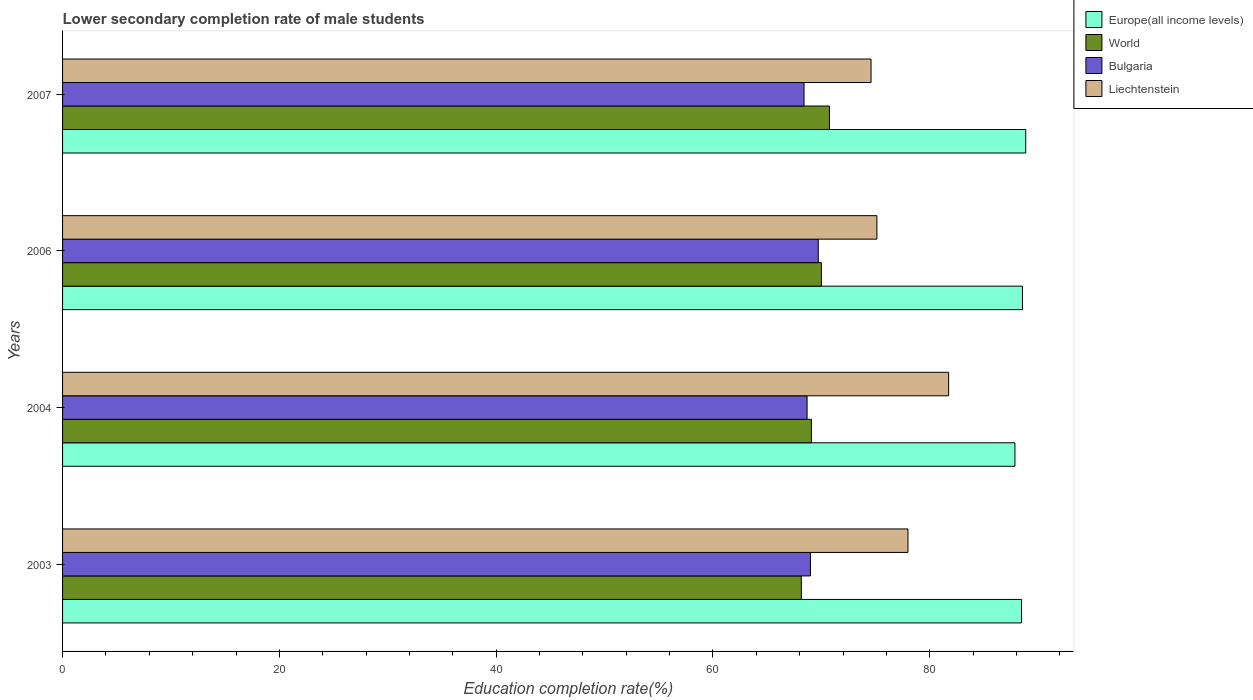Are the number of bars on each tick of the Y-axis equal?
Give a very brief answer. Yes. How many bars are there on the 2nd tick from the bottom?
Ensure brevity in your answer.  4. In how many cases, is the number of bars for a given year not equal to the number of legend labels?
Your answer should be compact. 0. What is the lower secondary completion rate of male students in Bulgaria in 2006?
Make the answer very short. 69.71. Across all years, what is the maximum lower secondary completion rate of male students in Europe(all income levels)?
Provide a succinct answer. 88.85. Across all years, what is the minimum lower secondary completion rate of male students in World?
Your response must be concise. 68.15. In which year was the lower secondary completion rate of male students in Europe(all income levels) maximum?
Your answer should be compact. 2007. What is the total lower secondary completion rate of male students in Europe(all income levels) in the graph?
Provide a succinct answer. 353.73. What is the difference between the lower secondary completion rate of male students in Europe(all income levels) in 2004 and that in 2006?
Your answer should be very brief. -0.69. What is the difference between the lower secondary completion rate of male students in Europe(all income levels) in 2007 and the lower secondary completion rate of male students in Liechtenstein in 2003?
Offer a very short reply. 10.86. What is the average lower secondary completion rate of male students in Bulgaria per year?
Make the answer very short. 68.95. In the year 2004, what is the difference between the lower secondary completion rate of male students in Liechtenstein and lower secondary completion rate of male students in Bulgaria?
Your answer should be very brief. 13.06. What is the ratio of the lower secondary completion rate of male students in Liechtenstein in 2003 to that in 2004?
Make the answer very short. 0.95. Is the lower secondary completion rate of male students in World in 2004 less than that in 2007?
Keep it short and to the point. Yes. Is the difference between the lower secondary completion rate of male students in Liechtenstein in 2003 and 2007 greater than the difference between the lower secondary completion rate of male students in Bulgaria in 2003 and 2007?
Your answer should be very brief. Yes. What is the difference between the highest and the second highest lower secondary completion rate of male students in Bulgaria?
Your response must be concise. 0.72. What is the difference between the highest and the lowest lower secondary completion rate of male students in Bulgaria?
Your answer should be very brief. 1.31. What does the 4th bar from the bottom in 2003 represents?
Provide a short and direct response. Liechtenstein. Is it the case that in every year, the sum of the lower secondary completion rate of male students in Bulgaria and lower secondary completion rate of male students in Liechtenstein is greater than the lower secondary completion rate of male students in Europe(all income levels)?
Your answer should be very brief. Yes. What is the difference between two consecutive major ticks on the X-axis?
Ensure brevity in your answer.  20. Does the graph contain grids?
Provide a short and direct response. No. How are the legend labels stacked?
Ensure brevity in your answer.  Vertical. What is the title of the graph?
Your response must be concise. Lower secondary completion rate of male students. What is the label or title of the X-axis?
Keep it short and to the point. Education completion rate(%). What is the label or title of the Y-axis?
Offer a very short reply. Years. What is the Education completion rate(%) in Europe(all income levels) in 2003?
Your answer should be very brief. 88.46. What is the Education completion rate(%) of World in 2003?
Offer a very short reply. 68.15. What is the Education completion rate(%) of Bulgaria in 2003?
Make the answer very short. 68.99. What is the Education completion rate(%) of Liechtenstein in 2003?
Your answer should be very brief. 77.99. What is the Education completion rate(%) in Europe(all income levels) in 2004?
Provide a short and direct response. 87.86. What is the Education completion rate(%) of World in 2004?
Offer a terse response. 69.08. What is the Education completion rate(%) in Bulgaria in 2004?
Provide a short and direct response. 68.68. What is the Education completion rate(%) in Liechtenstein in 2004?
Offer a very short reply. 81.74. What is the Education completion rate(%) of Europe(all income levels) in 2006?
Make the answer very short. 88.55. What is the Education completion rate(%) in World in 2006?
Keep it short and to the point. 70. What is the Education completion rate(%) of Bulgaria in 2006?
Your response must be concise. 69.71. What is the Education completion rate(%) of Liechtenstein in 2006?
Your answer should be compact. 75.12. What is the Education completion rate(%) in Europe(all income levels) in 2007?
Provide a short and direct response. 88.85. What is the Education completion rate(%) of World in 2007?
Your answer should be very brief. 70.75. What is the Education completion rate(%) in Bulgaria in 2007?
Give a very brief answer. 68.4. What is the Education completion rate(%) in Liechtenstein in 2007?
Provide a short and direct response. 74.58. Across all years, what is the maximum Education completion rate(%) in Europe(all income levels)?
Offer a terse response. 88.85. Across all years, what is the maximum Education completion rate(%) of World?
Make the answer very short. 70.75. Across all years, what is the maximum Education completion rate(%) in Bulgaria?
Offer a very short reply. 69.71. Across all years, what is the maximum Education completion rate(%) of Liechtenstein?
Ensure brevity in your answer.  81.74. Across all years, what is the minimum Education completion rate(%) in Europe(all income levels)?
Provide a short and direct response. 87.86. Across all years, what is the minimum Education completion rate(%) in World?
Make the answer very short. 68.15. Across all years, what is the minimum Education completion rate(%) in Bulgaria?
Give a very brief answer. 68.4. Across all years, what is the minimum Education completion rate(%) in Liechtenstein?
Give a very brief answer. 74.58. What is the total Education completion rate(%) of Europe(all income levels) in the graph?
Your answer should be very brief. 353.73. What is the total Education completion rate(%) of World in the graph?
Offer a very short reply. 277.99. What is the total Education completion rate(%) in Bulgaria in the graph?
Provide a succinct answer. 275.79. What is the total Education completion rate(%) in Liechtenstein in the graph?
Provide a short and direct response. 309.44. What is the difference between the Education completion rate(%) in Europe(all income levels) in 2003 and that in 2004?
Keep it short and to the point. 0.6. What is the difference between the Education completion rate(%) of World in 2003 and that in 2004?
Offer a very short reply. -0.93. What is the difference between the Education completion rate(%) of Bulgaria in 2003 and that in 2004?
Keep it short and to the point. 0.31. What is the difference between the Education completion rate(%) in Liechtenstein in 2003 and that in 2004?
Give a very brief answer. -3.75. What is the difference between the Education completion rate(%) in Europe(all income levels) in 2003 and that in 2006?
Provide a short and direct response. -0.09. What is the difference between the Education completion rate(%) in World in 2003 and that in 2006?
Provide a succinct answer. -1.85. What is the difference between the Education completion rate(%) in Bulgaria in 2003 and that in 2006?
Offer a terse response. -0.72. What is the difference between the Education completion rate(%) of Liechtenstein in 2003 and that in 2006?
Your answer should be compact. 2.87. What is the difference between the Education completion rate(%) of Europe(all income levels) in 2003 and that in 2007?
Your response must be concise. -0.39. What is the difference between the Education completion rate(%) of World in 2003 and that in 2007?
Your answer should be very brief. -2.6. What is the difference between the Education completion rate(%) in Bulgaria in 2003 and that in 2007?
Keep it short and to the point. 0.59. What is the difference between the Education completion rate(%) of Liechtenstein in 2003 and that in 2007?
Your response must be concise. 3.41. What is the difference between the Education completion rate(%) in Europe(all income levels) in 2004 and that in 2006?
Provide a succinct answer. -0.69. What is the difference between the Education completion rate(%) of World in 2004 and that in 2006?
Offer a very short reply. -0.92. What is the difference between the Education completion rate(%) in Bulgaria in 2004 and that in 2006?
Ensure brevity in your answer.  -1.03. What is the difference between the Education completion rate(%) of Liechtenstein in 2004 and that in 2006?
Keep it short and to the point. 6.62. What is the difference between the Education completion rate(%) in Europe(all income levels) in 2004 and that in 2007?
Offer a terse response. -1. What is the difference between the Education completion rate(%) in World in 2004 and that in 2007?
Ensure brevity in your answer.  -1.66. What is the difference between the Education completion rate(%) of Bulgaria in 2004 and that in 2007?
Ensure brevity in your answer.  0.28. What is the difference between the Education completion rate(%) in Liechtenstein in 2004 and that in 2007?
Make the answer very short. 7.16. What is the difference between the Education completion rate(%) in Europe(all income levels) in 2006 and that in 2007?
Make the answer very short. -0.3. What is the difference between the Education completion rate(%) in World in 2006 and that in 2007?
Your answer should be compact. -0.75. What is the difference between the Education completion rate(%) in Bulgaria in 2006 and that in 2007?
Offer a very short reply. 1.31. What is the difference between the Education completion rate(%) of Liechtenstein in 2006 and that in 2007?
Your answer should be very brief. 0.54. What is the difference between the Education completion rate(%) of Europe(all income levels) in 2003 and the Education completion rate(%) of World in 2004?
Provide a succinct answer. 19.38. What is the difference between the Education completion rate(%) of Europe(all income levels) in 2003 and the Education completion rate(%) of Bulgaria in 2004?
Provide a succinct answer. 19.78. What is the difference between the Education completion rate(%) in Europe(all income levels) in 2003 and the Education completion rate(%) in Liechtenstein in 2004?
Provide a short and direct response. 6.72. What is the difference between the Education completion rate(%) in World in 2003 and the Education completion rate(%) in Bulgaria in 2004?
Your answer should be very brief. -0.53. What is the difference between the Education completion rate(%) in World in 2003 and the Education completion rate(%) in Liechtenstein in 2004?
Give a very brief answer. -13.59. What is the difference between the Education completion rate(%) of Bulgaria in 2003 and the Education completion rate(%) of Liechtenstein in 2004?
Keep it short and to the point. -12.75. What is the difference between the Education completion rate(%) of Europe(all income levels) in 2003 and the Education completion rate(%) of World in 2006?
Provide a succinct answer. 18.46. What is the difference between the Education completion rate(%) of Europe(all income levels) in 2003 and the Education completion rate(%) of Bulgaria in 2006?
Provide a short and direct response. 18.75. What is the difference between the Education completion rate(%) of Europe(all income levels) in 2003 and the Education completion rate(%) of Liechtenstein in 2006?
Provide a short and direct response. 13.34. What is the difference between the Education completion rate(%) of World in 2003 and the Education completion rate(%) of Bulgaria in 2006?
Offer a very short reply. -1.56. What is the difference between the Education completion rate(%) of World in 2003 and the Education completion rate(%) of Liechtenstein in 2006?
Your response must be concise. -6.97. What is the difference between the Education completion rate(%) in Bulgaria in 2003 and the Education completion rate(%) in Liechtenstein in 2006?
Your answer should be compact. -6.13. What is the difference between the Education completion rate(%) of Europe(all income levels) in 2003 and the Education completion rate(%) of World in 2007?
Offer a terse response. 17.71. What is the difference between the Education completion rate(%) in Europe(all income levels) in 2003 and the Education completion rate(%) in Bulgaria in 2007?
Offer a terse response. 20.06. What is the difference between the Education completion rate(%) of Europe(all income levels) in 2003 and the Education completion rate(%) of Liechtenstein in 2007?
Provide a short and direct response. 13.88. What is the difference between the Education completion rate(%) of World in 2003 and the Education completion rate(%) of Bulgaria in 2007?
Offer a terse response. -0.25. What is the difference between the Education completion rate(%) of World in 2003 and the Education completion rate(%) of Liechtenstein in 2007?
Your answer should be very brief. -6.43. What is the difference between the Education completion rate(%) in Bulgaria in 2003 and the Education completion rate(%) in Liechtenstein in 2007?
Your answer should be very brief. -5.59. What is the difference between the Education completion rate(%) of Europe(all income levels) in 2004 and the Education completion rate(%) of World in 2006?
Offer a very short reply. 17.86. What is the difference between the Education completion rate(%) in Europe(all income levels) in 2004 and the Education completion rate(%) in Bulgaria in 2006?
Offer a very short reply. 18.14. What is the difference between the Education completion rate(%) in Europe(all income levels) in 2004 and the Education completion rate(%) in Liechtenstein in 2006?
Give a very brief answer. 12.73. What is the difference between the Education completion rate(%) in World in 2004 and the Education completion rate(%) in Bulgaria in 2006?
Ensure brevity in your answer.  -0.63. What is the difference between the Education completion rate(%) of World in 2004 and the Education completion rate(%) of Liechtenstein in 2006?
Your answer should be compact. -6.04. What is the difference between the Education completion rate(%) in Bulgaria in 2004 and the Education completion rate(%) in Liechtenstein in 2006?
Your answer should be compact. -6.44. What is the difference between the Education completion rate(%) in Europe(all income levels) in 2004 and the Education completion rate(%) in World in 2007?
Ensure brevity in your answer.  17.11. What is the difference between the Education completion rate(%) in Europe(all income levels) in 2004 and the Education completion rate(%) in Bulgaria in 2007?
Make the answer very short. 19.46. What is the difference between the Education completion rate(%) of Europe(all income levels) in 2004 and the Education completion rate(%) of Liechtenstein in 2007?
Your response must be concise. 13.27. What is the difference between the Education completion rate(%) in World in 2004 and the Education completion rate(%) in Bulgaria in 2007?
Give a very brief answer. 0.68. What is the difference between the Education completion rate(%) in World in 2004 and the Education completion rate(%) in Liechtenstein in 2007?
Your answer should be compact. -5.5. What is the difference between the Education completion rate(%) in Bulgaria in 2004 and the Education completion rate(%) in Liechtenstein in 2007?
Offer a very short reply. -5.9. What is the difference between the Education completion rate(%) of Europe(all income levels) in 2006 and the Education completion rate(%) of World in 2007?
Give a very brief answer. 17.8. What is the difference between the Education completion rate(%) in Europe(all income levels) in 2006 and the Education completion rate(%) in Bulgaria in 2007?
Offer a very short reply. 20.15. What is the difference between the Education completion rate(%) in Europe(all income levels) in 2006 and the Education completion rate(%) in Liechtenstein in 2007?
Ensure brevity in your answer.  13.97. What is the difference between the Education completion rate(%) in World in 2006 and the Education completion rate(%) in Bulgaria in 2007?
Provide a short and direct response. 1.6. What is the difference between the Education completion rate(%) in World in 2006 and the Education completion rate(%) in Liechtenstein in 2007?
Provide a succinct answer. -4.58. What is the difference between the Education completion rate(%) in Bulgaria in 2006 and the Education completion rate(%) in Liechtenstein in 2007?
Provide a succinct answer. -4.87. What is the average Education completion rate(%) in Europe(all income levels) per year?
Give a very brief answer. 88.43. What is the average Education completion rate(%) of World per year?
Provide a succinct answer. 69.5. What is the average Education completion rate(%) in Bulgaria per year?
Provide a short and direct response. 68.95. What is the average Education completion rate(%) in Liechtenstein per year?
Make the answer very short. 77.36. In the year 2003, what is the difference between the Education completion rate(%) in Europe(all income levels) and Education completion rate(%) in World?
Offer a terse response. 20.31. In the year 2003, what is the difference between the Education completion rate(%) in Europe(all income levels) and Education completion rate(%) in Bulgaria?
Your answer should be very brief. 19.47. In the year 2003, what is the difference between the Education completion rate(%) of Europe(all income levels) and Education completion rate(%) of Liechtenstein?
Provide a short and direct response. 10.47. In the year 2003, what is the difference between the Education completion rate(%) in World and Education completion rate(%) in Bulgaria?
Offer a terse response. -0.84. In the year 2003, what is the difference between the Education completion rate(%) of World and Education completion rate(%) of Liechtenstein?
Offer a terse response. -9.84. In the year 2003, what is the difference between the Education completion rate(%) of Bulgaria and Education completion rate(%) of Liechtenstein?
Offer a very short reply. -9. In the year 2004, what is the difference between the Education completion rate(%) of Europe(all income levels) and Education completion rate(%) of World?
Make the answer very short. 18.77. In the year 2004, what is the difference between the Education completion rate(%) of Europe(all income levels) and Education completion rate(%) of Bulgaria?
Keep it short and to the point. 19.17. In the year 2004, what is the difference between the Education completion rate(%) of Europe(all income levels) and Education completion rate(%) of Liechtenstein?
Your answer should be compact. 6.12. In the year 2004, what is the difference between the Education completion rate(%) in World and Education completion rate(%) in Bulgaria?
Ensure brevity in your answer.  0.4. In the year 2004, what is the difference between the Education completion rate(%) in World and Education completion rate(%) in Liechtenstein?
Your answer should be very brief. -12.66. In the year 2004, what is the difference between the Education completion rate(%) in Bulgaria and Education completion rate(%) in Liechtenstein?
Offer a very short reply. -13.06. In the year 2006, what is the difference between the Education completion rate(%) of Europe(all income levels) and Education completion rate(%) of World?
Offer a very short reply. 18.55. In the year 2006, what is the difference between the Education completion rate(%) in Europe(all income levels) and Education completion rate(%) in Bulgaria?
Provide a succinct answer. 18.84. In the year 2006, what is the difference between the Education completion rate(%) of Europe(all income levels) and Education completion rate(%) of Liechtenstein?
Ensure brevity in your answer.  13.43. In the year 2006, what is the difference between the Education completion rate(%) in World and Education completion rate(%) in Bulgaria?
Offer a very short reply. 0.29. In the year 2006, what is the difference between the Education completion rate(%) in World and Education completion rate(%) in Liechtenstein?
Make the answer very short. -5.12. In the year 2006, what is the difference between the Education completion rate(%) in Bulgaria and Education completion rate(%) in Liechtenstein?
Offer a very short reply. -5.41. In the year 2007, what is the difference between the Education completion rate(%) in Europe(all income levels) and Education completion rate(%) in World?
Your answer should be compact. 18.11. In the year 2007, what is the difference between the Education completion rate(%) of Europe(all income levels) and Education completion rate(%) of Bulgaria?
Make the answer very short. 20.45. In the year 2007, what is the difference between the Education completion rate(%) in Europe(all income levels) and Education completion rate(%) in Liechtenstein?
Provide a short and direct response. 14.27. In the year 2007, what is the difference between the Education completion rate(%) of World and Education completion rate(%) of Bulgaria?
Offer a very short reply. 2.35. In the year 2007, what is the difference between the Education completion rate(%) in World and Education completion rate(%) in Liechtenstein?
Offer a very short reply. -3.83. In the year 2007, what is the difference between the Education completion rate(%) in Bulgaria and Education completion rate(%) in Liechtenstein?
Offer a very short reply. -6.18. What is the ratio of the Education completion rate(%) of World in 2003 to that in 2004?
Your answer should be very brief. 0.99. What is the ratio of the Education completion rate(%) in Bulgaria in 2003 to that in 2004?
Your answer should be very brief. 1. What is the ratio of the Education completion rate(%) of Liechtenstein in 2003 to that in 2004?
Your response must be concise. 0.95. What is the ratio of the Education completion rate(%) in World in 2003 to that in 2006?
Make the answer very short. 0.97. What is the ratio of the Education completion rate(%) of Bulgaria in 2003 to that in 2006?
Offer a very short reply. 0.99. What is the ratio of the Education completion rate(%) in Liechtenstein in 2003 to that in 2006?
Provide a succinct answer. 1.04. What is the ratio of the Education completion rate(%) of World in 2003 to that in 2007?
Your answer should be compact. 0.96. What is the ratio of the Education completion rate(%) of Bulgaria in 2003 to that in 2007?
Offer a terse response. 1.01. What is the ratio of the Education completion rate(%) of Liechtenstein in 2003 to that in 2007?
Offer a very short reply. 1.05. What is the ratio of the Education completion rate(%) in Europe(all income levels) in 2004 to that in 2006?
Your answer should be very brief. 0.99. What is the ratio of the Education completion rate(%) of World in 2004 to that in 2006?
Keep it short and to the point. 0.99. What is the ratio of the Education completion rate(%) of Bulgaria in 2004 to that in 2006?
Your answer should be compact. 0.99. What is the ratio of the Education completion rate(%) in Liechtenstein in 2004 to that in 2006?
Ensure brevity in your answer.  1.09. What is the ratio of the Education completion rate(%) in World in 2004 to that in 2007?
Ensure brevity in your answer.  0.98. What is the ratio of the Education completion rate(%) of Liechtenstein in 2004 to that in 2007?
Your answer should be compact. 1.1. What is the ratio of the Education completion rate(%) in Bulgaria in 2006 to that in 2007?
Offer a very short reply. 1.02. What is the ratio of the Education completion rate(%) in Liechtenstein in 2006 to that in 2007?
Your response must be concise. 1.01. What is the difference between the highest and the second highest Education completion rate(%) in Europe(all income levels)?
Your answer should be compact. 0.3. What is the difference between the highest and the second highest Education completion rate(%) of World?
Ensure brevity in your answer.  0.75. What is the difference between the highest and the second highest Education completion rate(%) of Bulgaria?
Your answer should be compact. 0.72. What is the difference between the highest and the second highest Education completion rate(%) of Liechtenstein?
Give a very brief answer. 3.75. What is the difference between the highest and the lowest Education completion rate(%) of World?
Provide a succinct answer. 2.6. What is the difference between the highest and the lowest Education completion rate(%) in Bulgaria?
Provide a short and direct response. 1.31. What is the difference between the highest and the lowest Education completion rate(%) of Liechtenstein?
Ensure brevity in your answer.  7.16. 